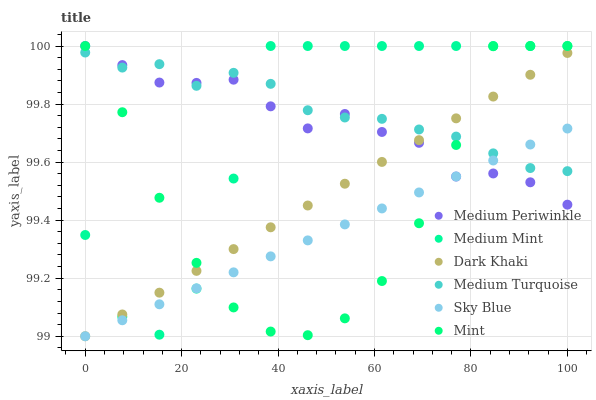Does Sky Blue have the minimum area under the curve?
Answer yes or no. Yes. Does Medium Turquoise have the maximum area under the curve?
Answer yes or no. Yes. Does Medium Periwinkle have the minimum area under the curve?
Answer yes or no. No. Does Medium Periwinkle have the maximum area under the curve?
Answer yes or no. No. Is Sky Blue the smoothest?
Answer yes or no. Yes. Is Medium Mint the roughest?
Answer yes or no. Yes. Is Medium Periwinkle the smoothest?
Answer yes or no. No. Is Medium Periwinkle the roughest?
Answer yes or no. No. Does Dark Khaki have the lowest value?
Answer yes or no. Yes. Does Medium Periwinkle have the lowest value?
Answer yes or no. No. Does Mint have the highest value?
Answer yes or no. Yes. Does Dark Khaki have the highest value?
Answer yes or no. No. Does Mint intersect Sky Blue?
Answer yes or no. Yes. Is Mint less than Sky Blue?
Answer yes or no. No. Is Mint greater than Sky Blue?
Answer yes or no. No. 